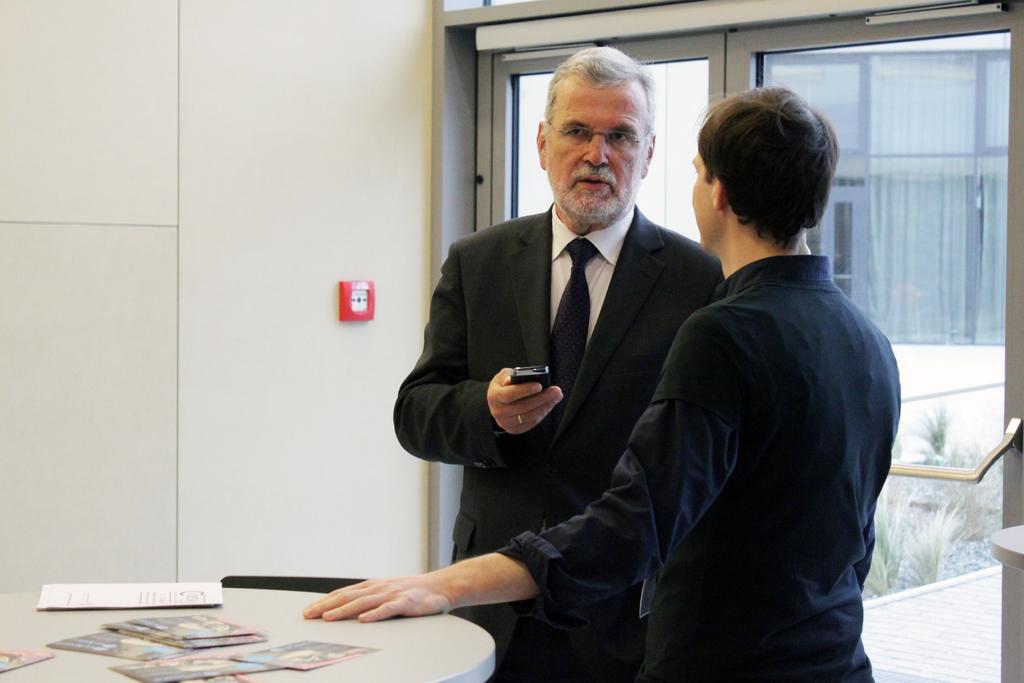Please provide a concise description of this image. In this picture we can see two persons standing on the floor. This is the table. And there is a wall and this is the glass door. 